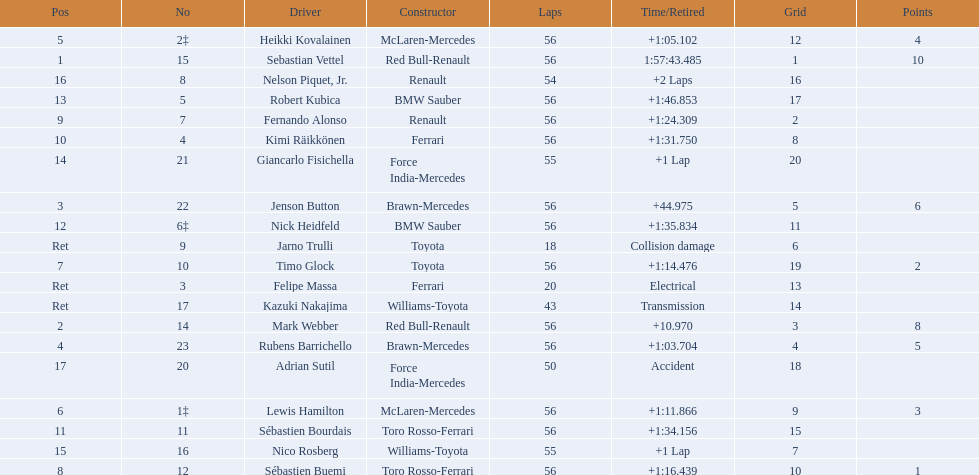Who are all the drivers? Sebastian Vettel, Mark Webber, Jenson Button, Rubens Barrichello, Heikki Kovalainen, Lewis Hamilton, Timo Glock, Sébastien Buemi, Fernando Alonso, Kimi Räikkönen, Sébastien Bourdais, Nick Heidfeld, Robert Kubica, Giancarlo Fisichella, Nico Rosberg, Nelson Piquet, Jr., Adrian Sutil, Kazuki Nakajima, Felipe Massa, Jarno Trulli. What were their finishing times? 1:57:43.485, +10.970, +44.975, +1:03.704, +1:05.102, +1:11.866, +1:14.476, +1:16.439, +1:24.309, +1:31.750, +1:34.156, +1:35.834, +1:46.853, +1 Lap, +1 Lap, +2 Laps, Accident, Transmission, Electrical, Collision damage. Who finished last? Robert Kubica. 